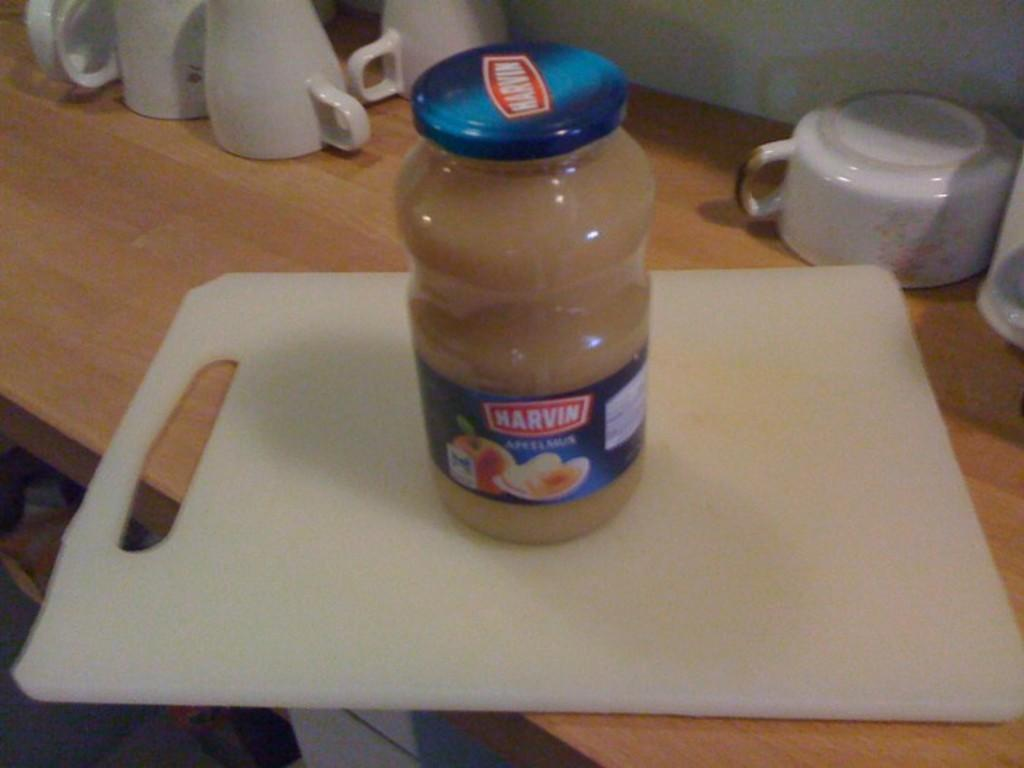<image>
Relay a brief, clear account of the picture shown. A can of some kind of spread has the brand Marvin printed on it. 